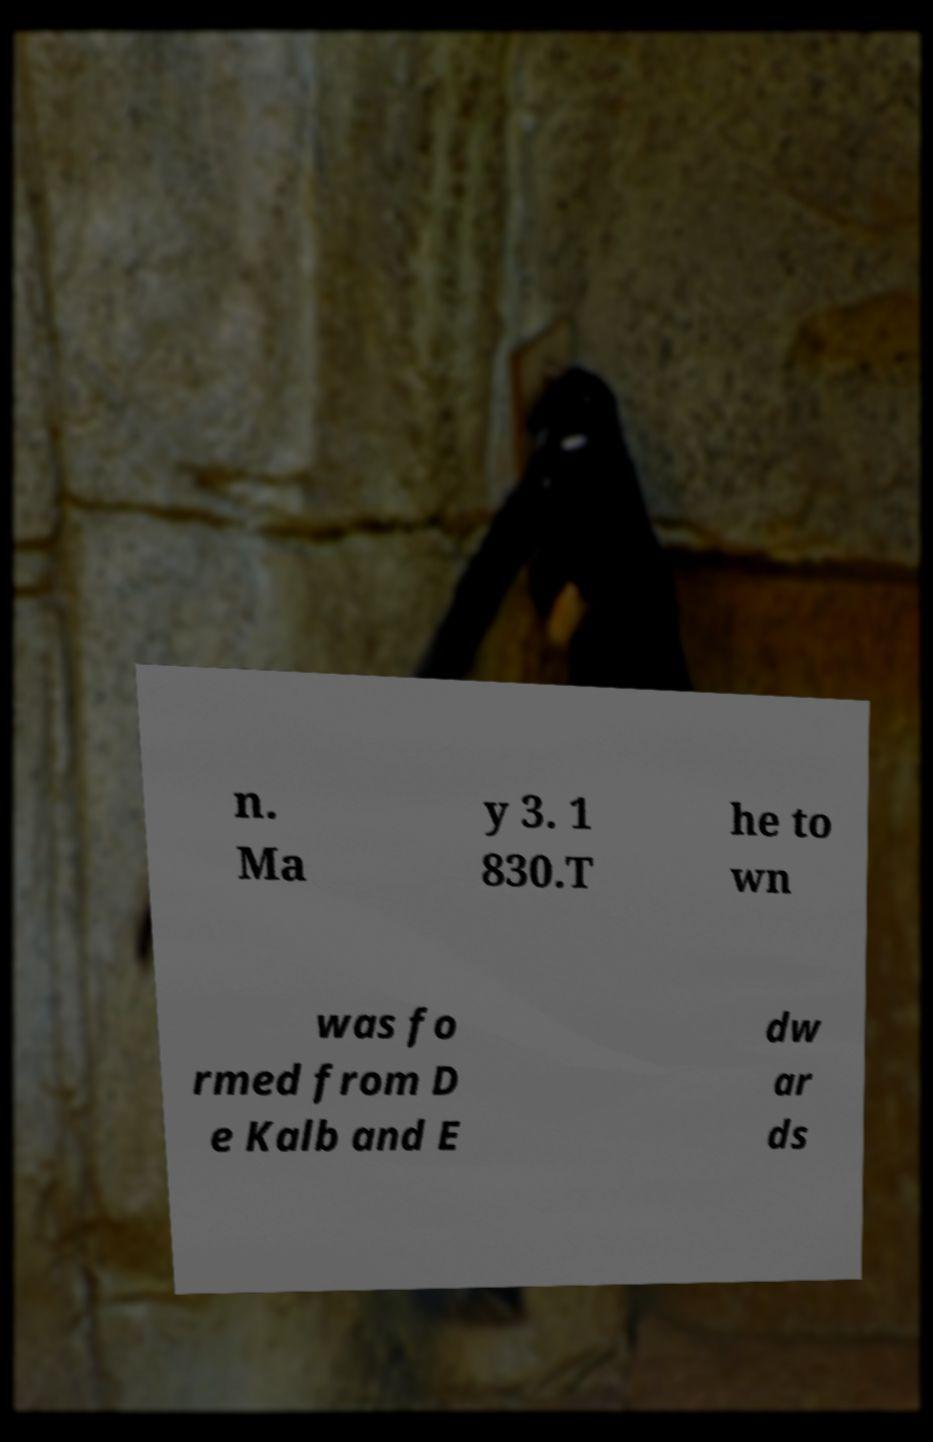Can you read and provide the text displayed in the image?This photo seems to have some interesting text. Can you extract and type it out for me? n. Ma y 3. 1 830.T he to wn was fo rmed from D e Kalb and E dw ar ds 